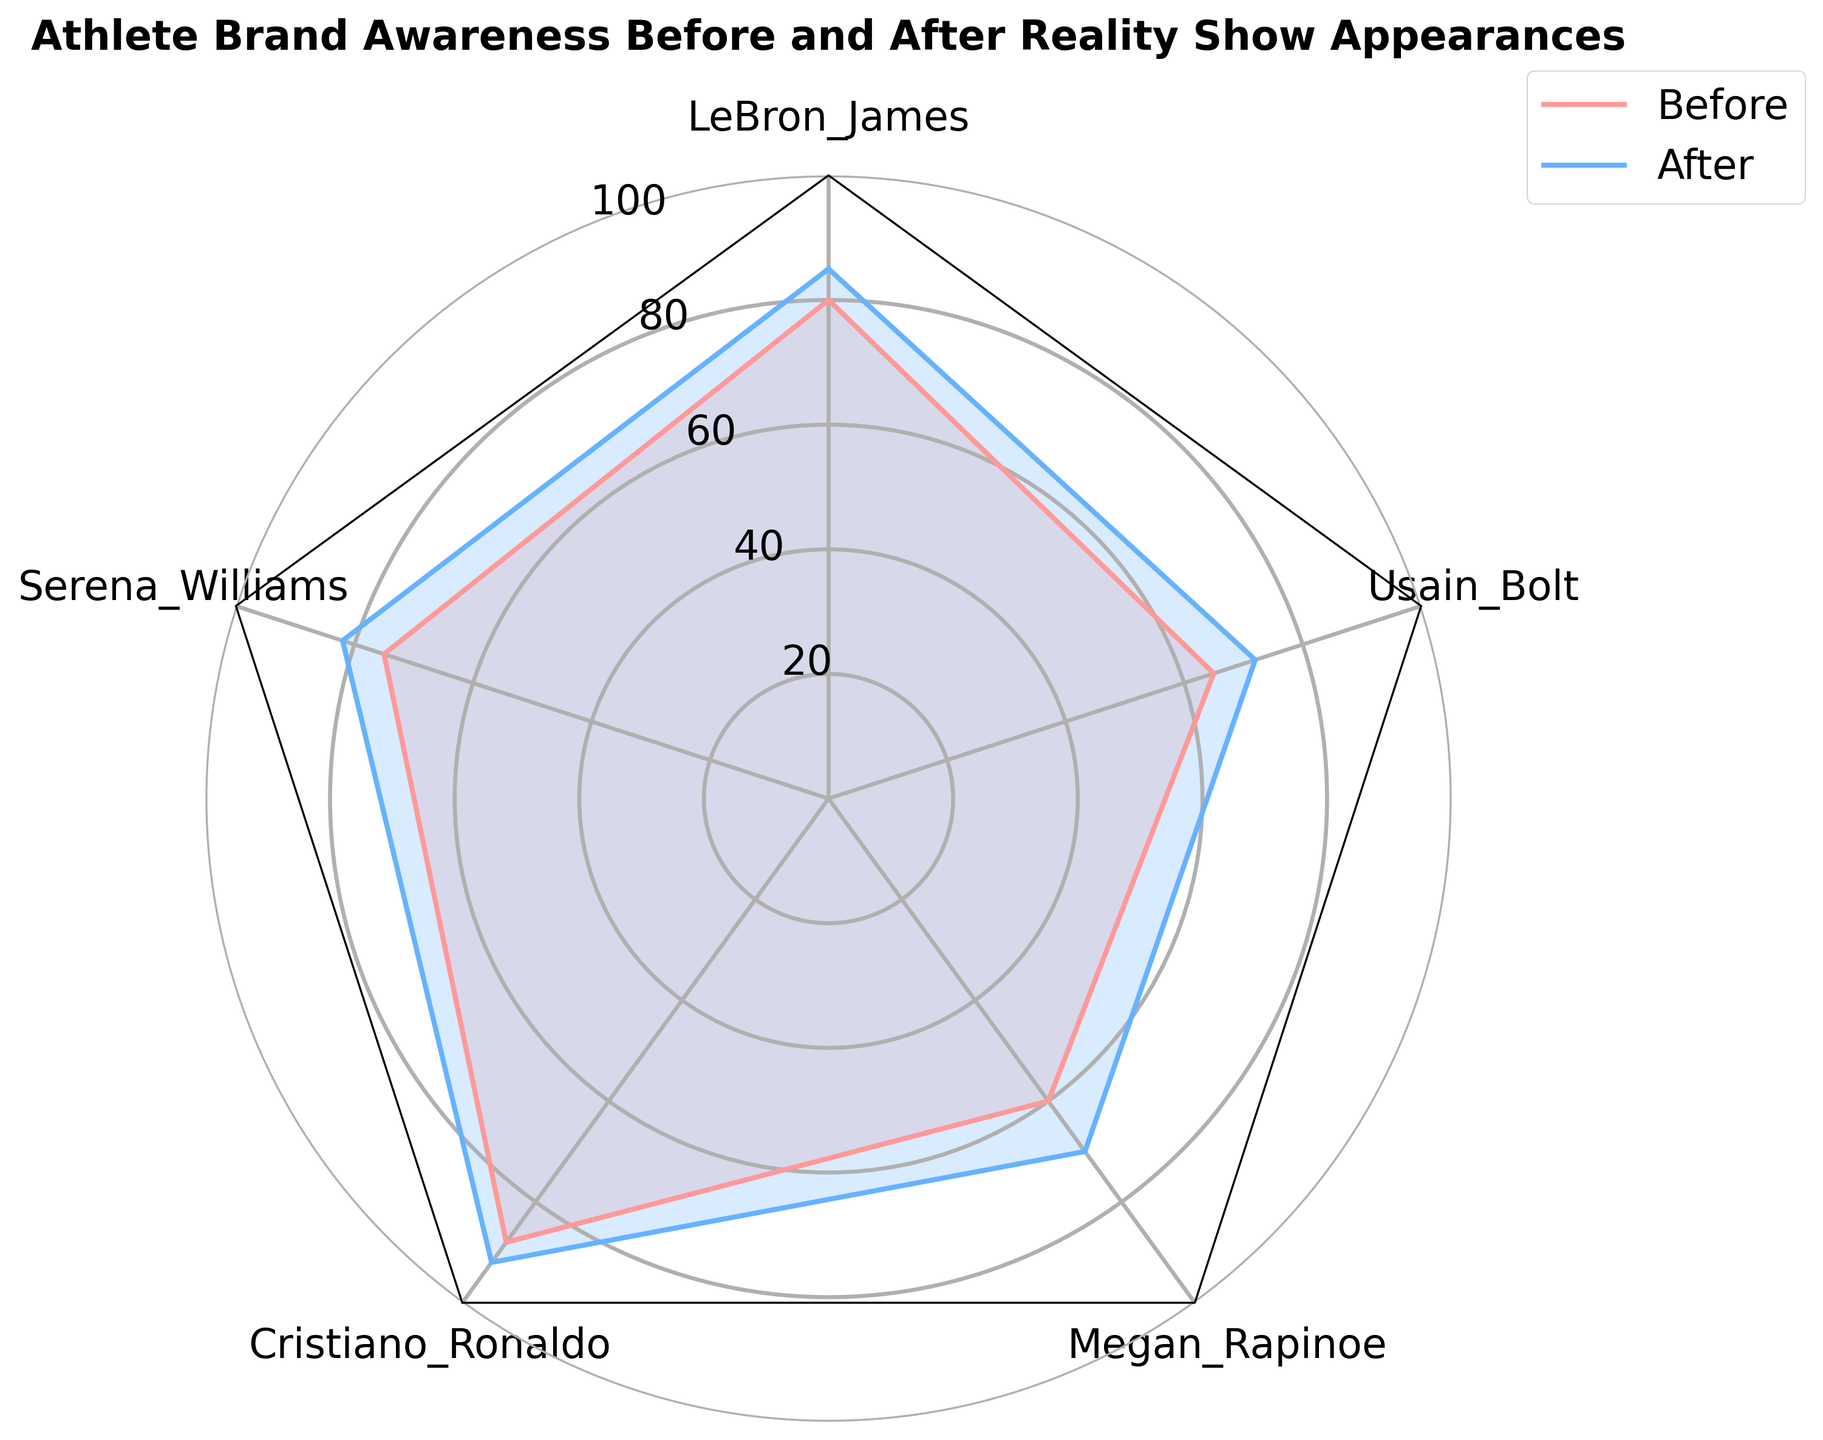Which athlete had the highest brand awareness before the reality show appearances? LeBron James had the highest brand awareness before the reality show, as indicated by the value of 88 displayed on the radar chart.
Answer: Cristiano Ronaldo How much did Megan Rapinoe's brand awareness increase after appearing in the reality show? Megan Rapinoe's brand awareness before and after the show are 60 and 70, respectively. The difference is 70 - 60 = 10.
Answer: 10 Which athlete had the smallest increase in brand awareness after the reality show appearances? Calculating the increase for each athlete: LeBron James (85-80=5), Serena Williams (82-75=7), Cristiano Ronaldo (92-88=4), Megan Rapinoe (70-60=10), Usain Bolt (72-65=7). Cristiano Ronaldo had the smallest increase of 4.
Answer: Cristiano Ronaldo What is the average brand awareness after the reality show appearances for all athletes? The brand awareness values after the show are 85, 82, 92, 70, and 72. The average is calculated as (85+82+92+70+72)/5 = 80.2.
Answer: 80.2 Did Serena Williams pass the 80-point mark in brand awareness after the reality show? Serena Williams' brand awareness after the show is 82, which is greater than 80.
Answer: Yes Which athlete showed the greatest improvement in brand awareness after the reality show appearances? Calculating the improvement for each athlete: LeBron James (85-80=5), Serena Williams (82-75=7), Cristiano Ronaldo (92-88=4), Megan Rapinoe (70-60=10), Usain Bolt (72-65=7). Megan Rapinoe had the greatest improvement with an increase of 10.
Answer: Megan Rapinoe What is the median brand awareness before the reality show appearances for the athletes? The brand awareness values before the show are 80, 75, 88, 60, and 65. Arranging them in ascending order: 60, 65, 75, 80, 88. The median value for an odd number of data points is the middle value, which is 75.
Answer: 75 Is there any athlete whose brand awareness did not reach at least 70 after the reality show appearances? Examining the after values: 85, 82, 92, 70, and 72. All athletes reached at least 70 after the show.
Answer: No Comparing LeBron James and Serena Williams, who had a higher improvement in brand awareness after the reality show? LeBron James improved from 80 to 85 (5 points increase) and Serena Williams improved from 75 to 82 (7 points increase). Serena Williams had a higher improvement.
Answer: Serena Williams 